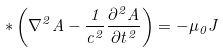<formula> <loc_0><loc_0><loc_500><loc_500>\ast \left ( \nabla ^ { 2 } A - \frac { 1 } { c ^ { 2 } } \frac { \partial ^ { 2 } A } { \partial t ^ { 2 } } \right ) = - \mu _ { 0 } J</formula> 